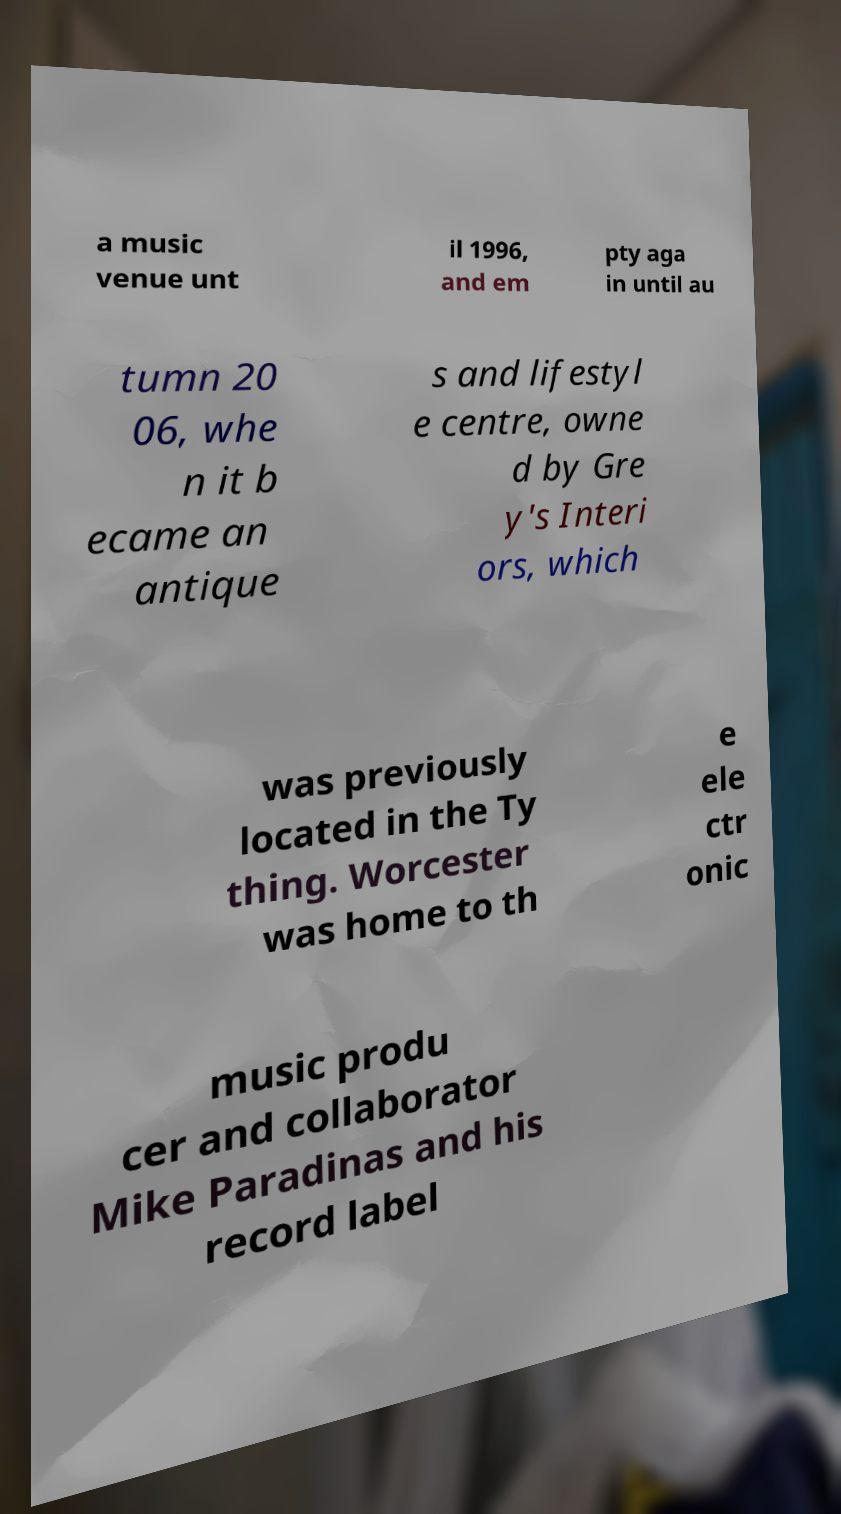Can you accurately transcribe the text from the provided image for me? a music venue unt il 1996, and em pty aga in until au tumn 20 06, whe n it b ecame an antique s and lifestyl e centre, owne d by Gre y's Interi ors, which was previously located in the Ty thing. Worcester was home to th e ele ctr onic music produ cer and collaborator Mike Paradinas and his record label 